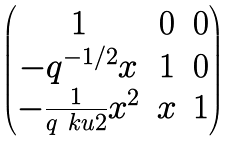Convert formula to latex. <formula><loc_0><loc_0><loc_500><loc_500>\begin{pmatrix} 1 & 0 & 0 \\ - q ^ { - 1 / 2 } x & 1 & 0 \\ - \frac { 1 } { q \ k u { 2 } } x ^ { 2 } & x & 1 \end{pmatrix}</formula> 